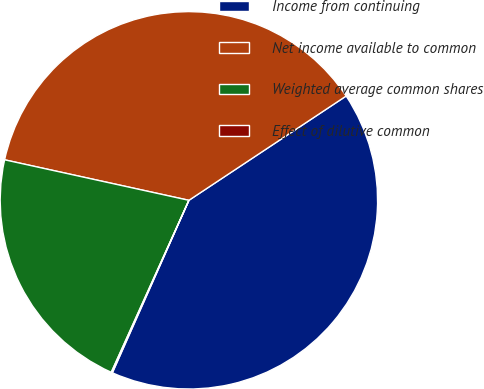<chart> <loc_0><loc_0><loc_500><loc_500><pie_chart><fcel>Income from continuing<fcel>Net income available to common<fcel>Weighted average common shares<fcel>Effect of dilutive common<nl><fcel>40.97%<fcel>37.24%<fcel>21.7%<fcel>0.1%<nl></chart> 